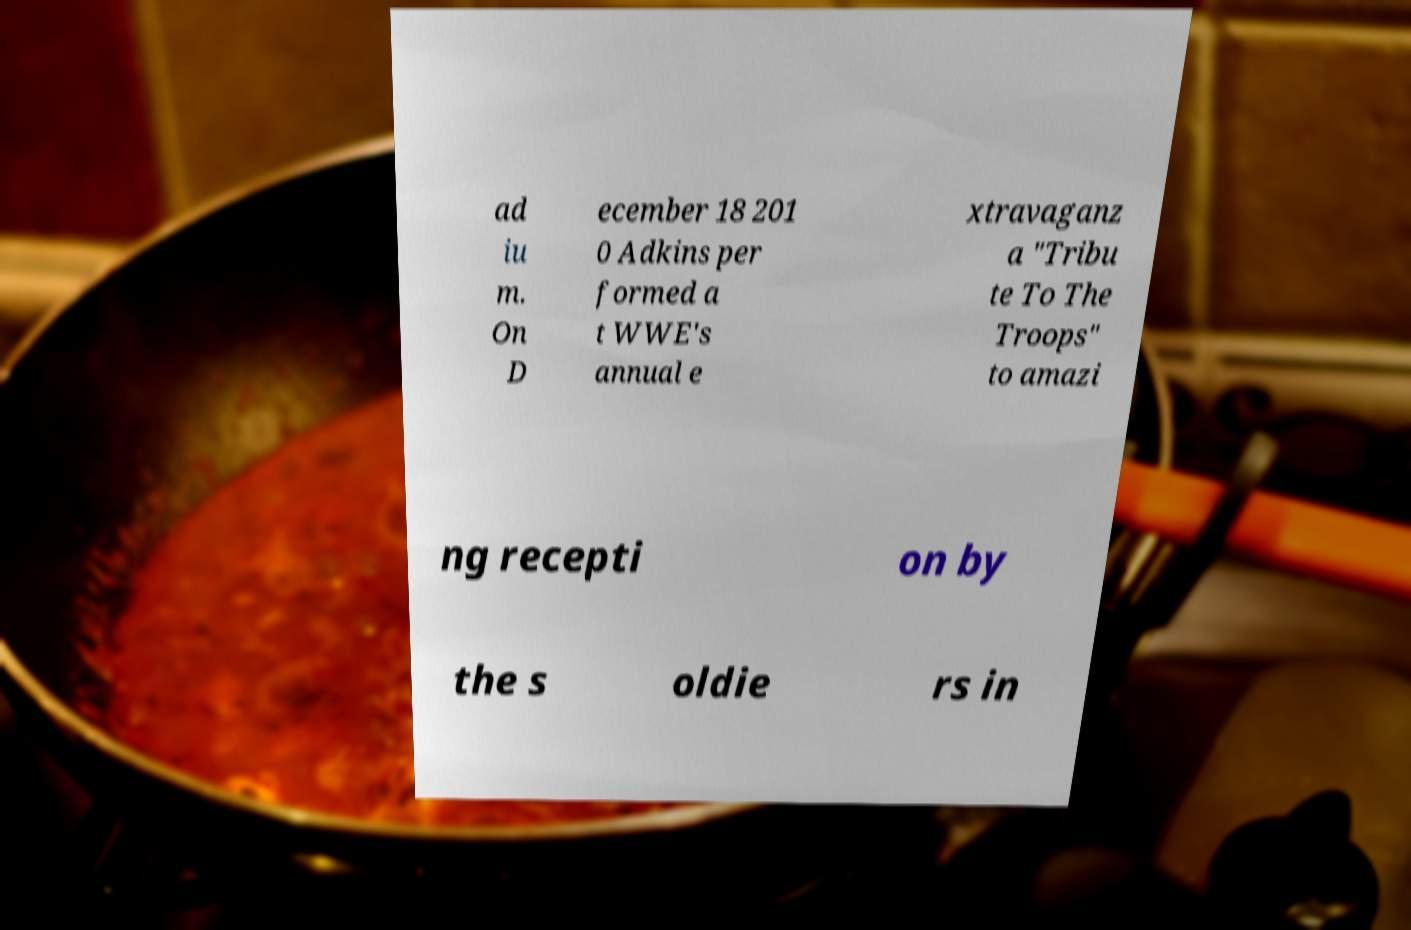There's text embedded in this image that I need extracted. Can you transcribe it verbatim? ad iu m. On D ecember 18 201 0 Adkins per formed a t WWE's annual e xtravaganz a "Tribu te To The Troops" to amazi ng recepti on by the s oldie rs in 